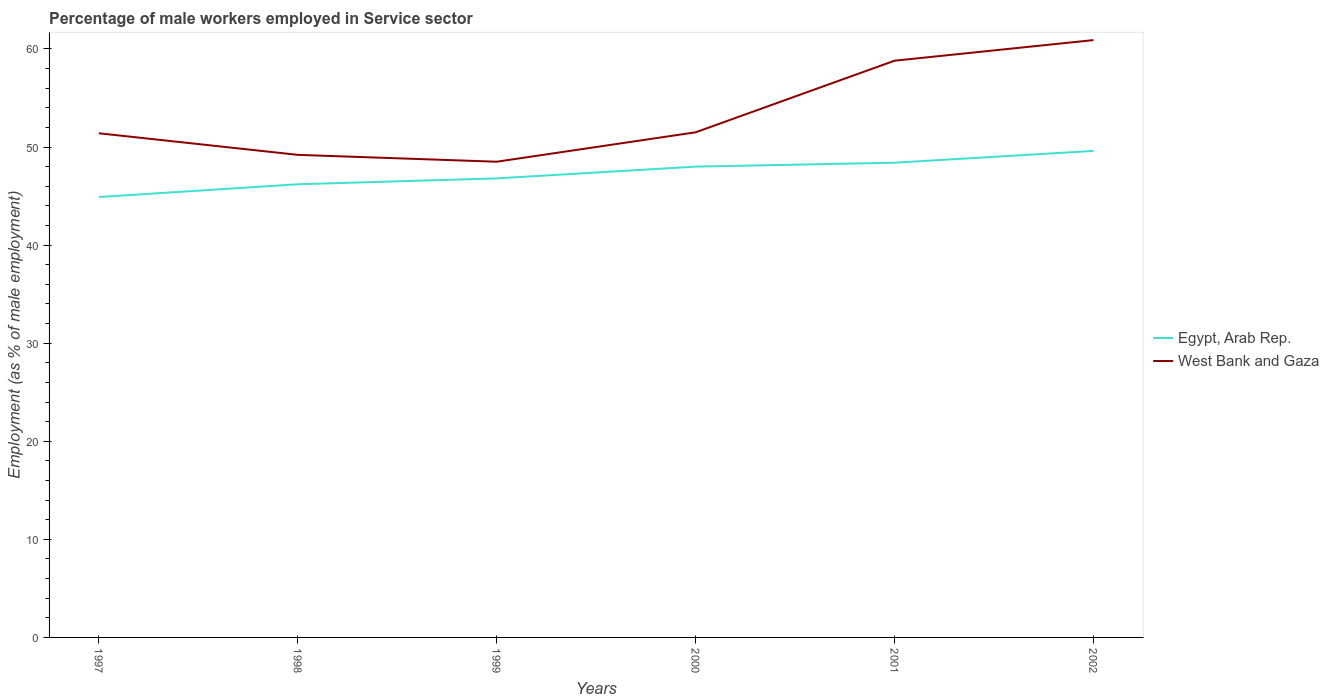Does the line corresponding to Egypt, Arab Rep. intersect with the line corresponding to West Bank and Gaza?
Keep it short and to the point. No. Is the number of lines equal to the number of legend labels?
Your answer should be compact. Yes. Across all years, what is the maximum percentage of male workers employed in Service sector in Egypt, Arab Rep.?
Offer a very short reply. 44.9. What is the total percentage of male workers employed in Service sector in Egypt, Arab Rep. in the graph?
Give a very brief answer. -1.6. What is the difference between the highest and the second highest percentage of male workers employed in Service sector in West Bank and Gaza?
Offer a terse response. 12.4. Is the percentage of male workers employed in Service sector in Egypt, Arab Rep. strictly greater than the percentage of male workers employed in Service sector in West Bank and Gaza over the years?
Ensure brevity in your answer.  Yes. Does the graph contain grids?
Offer a very short reply. No. Where does the legend appear in the graph?
Your answer should be very brief. Center right. How many legend labels are there?
Provide a succinct answer. 2. What is the title of the graph?
Your answer should be very brief. Percentage of male workers employed in Service sector. Does "Saudi Arabia" appear as one of the legend labels in the graph?
Ensure brevity in your answer.  No. What is the label or title of the X-axis?
Your response must be concise. Years. What is the label or title of the Y-axis?
Give a very brief answer. Employment (as % of male employment). What is the Employment (as % of male employment) of Egypt, Arab Rep. in 1997?
Your answer should be very brief. 44.9. What is the Employment (as % of male employment) in West Bank and Gaza in 1997?
Offer a very short reply. 51.4. What is the Employment (as % of male employment) in Egypt, Arab Rep. in 1998?
Keep it short and to the point. 46.2. What is the Employment (as % of male employment) of West Bank and Gaza in 1998?
Keep it short and to the point. 49.2. What is the Employment (as % of male employment) of Egypt, Arab Rep. in 1999?
Offer a very short reply. 46.8. What is the Employment (as % of male employment) of West Bank and Gaza in 1999?
Keep it short and to the point. 48.5. What is the Employment (as % of male employment) of Egypt, Arab Rep. in 2000?
Your answer should be compact. 48. What is the Employment (as % of male employment) in West Bank and Gaza in 2000?
Provide a succinct answer. 51.5. What is the Employment (as % of male employment) of Egypt, Arab Rep. in 2001?
Your answer should be very brief. 48.4. What is the Employment (as % of male employment) of West Bank and Gaza in 2001?
Your answer should be very brief. 58.8. What is the Employment (as % of male employment) in Egypt, Arab Rep. in 2002?
Your response must be concise. 49.6. What is the Employment (as % of male employment) in West Bank and Gaza in 2002?
Provide a short and direct response. 60.9. Across all years, what is the maximum Employment (as % of male employment) of Egypt, Arab Rep.?
Provide a succinct answer. 49.6. Across all years, what is the maximum Employment (as % of male employment) of West Bank and Gaza?
Your answer should be compact. 60.9. Across all years, what is the minimum Employment (as % of male employment) of Egypt, Arab Rep.?
Offer a very short reply. 44.9. Across all years, what is the minimum Employment (as % of male employment) of West Bank and Gaza?
Keep it short and to the point. 48.5. What is the total Employment (as % of male employment) of Egypt, Arab Rep. in the graph?
Your response must be concise. 283.9. What is the total Employment (as % of male employment) of West Bank and Gaza in the graph?
Give a very brief answer. 320.3. What is the difference between the Employment (as % of male employment) of Egypt, Arab Rep. in 1997 and that in 1998?
Offer a terse response. -1.3. What is the difference between the Employment (as % of male employment) in West Bank and Gaza in 1997 and that in 1998?
Your answer should be compact. 2.2. What is the difference between the Employment (as % of male employment) in Egypt, Arab Rep. in 1997 and that in 2000?
Your answer should be compact. -3.1. What is the difference between the Employment (as % of male employment) of Egypt, Arab Rep. in 1997 and that in 2001?
Give a very brief answer. -3.5. What is the difference between the Employment (as % of male employment) in West Bank and Gaza in 1997 and that in 2001?
Offer a very short reply. -7.4. What is the difference between the Employment (as % of male employment) of West Bank and Gaza in 1997 and that in 2002?
Keep it short and to the point. -9.5. What is the difference between the Employment (as % of male employment) in Egypt, Arab Rep. in 1998 and that in 1999?
Your answer should be compact. -0.6. What is the difference between the Employment (as % of male employment) of West Bank and Gaza in 1998 and that in 1999?
Offer a very short reply. 0.7. What is the difference between the Employment (as % of male employment) of West Bank and Gaza in 1998 and that in 2001?
Ensure brevity in your answer.  -9.6. What is the difference between the Employment (as % of male employment) of West Bank and Gaza in 1998 and that in 2002?
Offer a very short reply. -11.7. What is the difference between the Employment (as % of male employment) of Egypt, Arab Rep. in 1999 and that in 2000?
Provide a short and direct response. -1.2. What is the difference between the Employment (as % of male employment) of West Bank and Gaza in 1999 and that in 2001?
Your response must be concise. -10.3. What is the difference between the Employment (as % of male employment) of Egypt, Arab Rep. in 2000 and that in 2001?
Provide a succinct answer. -0.4. What is the difference between the Employment (as % of male employment) of West Bank and Gaza in 2000 and that in 2001?
Make the answer very short. -7.3. What is the difference between the Employment (as % of male employment) of Egypt, Arab Rep. in 2000 and that in 2002?
Offer a terse response. -1.6. What is the difference between the Employment (as % of male employment) of Egypt, Arab Rep. in 2001 and that in 2002?
Offer a terse response. -1.2. What is the difference between the Employment (as % of male employment) of Egypt, Arab Rep. in 1997 and the Employment (as % of male employment) of West Bank and Gaza in 1998?
Your answer should be very brief. -4.3. What is the difference between the Employment (as % of male employment) in Egypt, Arab Rep. in 1997 and the Employment (as % of male employment) in West Bank and Gaza in 2001?
Keep it short and to the point. -13.9. What is the difference between the Employment (as % of male employment) in Egypt, Arab Rep. in 1997 and the Employment (as % of male employment) in West Bank and Gaza in 2002?
Ensure brevity in your answer.  -16. What is the difference between the Employment (as % of male employment) in Egypt, Arab Rep. in 1998 and the Employment (as % of male employment) in West Bank and Gaza in 2000?
Your response must be concise. -5.3. What is the difference between the Employment (as % of male employment) of Egypt, Arab Rep. in 1998 and the Employment (as % of male employment) of West Bank and Gaza in 2002?
Your answer should be very brief. -14.7. What is the difference between the Employment (as % of male employment) in Egypt, Arab Rep. in 1999 and the Employment (as % of male employment) in West Bank and Gaza in 2000?
Offer a terse response. -4.7. What is the difference between the Employment (as % of male employment) of Egypt, Arab Rep. in 1999 and the Employment (as % of male employment) of West Bank and Gaza in 2002?
Ensure brevity in your answer.  -14.1. What is the difference between the Employment (as % of male employment) of Egypt, Arab Rep. in 2000 and the Employment (as % of male employment) of West Bank and Gaza in 2001?
Give a very brief answer. -10.8. What is the average Employment (as % of male employment) of Egypt, Arab Rep. per year?
Offer a very short reply. 47.32. What is the average Employment (as % of male employment) of West Bank and Gaza per year?
Offer a terse response. 53.38. In the year 1997, what is the difference between the Employment (as % of male employment) in Egypt, Arab Rep. and Employment (as % of male employment) in West Bank and Gaza?
Your response must be concise. -6.5. In the year 2000, what is the difference between the Employment (as % of male employment) in Egypt, Arab Rep. and Employment (as % of male employment) in West Bank and Gaza?
Keep it short and to the point. -3.5. In the year 2002, what is the difference between the Employment (as % of male employment) in Egypt, Arab Rep. and Employment (as % of male employment) in West Bank and Gaza?
Your answer should be very brief. -11.3. What is the ratio of the Employment (as % of male employment) in Egypt, Arab Rep. in 1997 to that in 1998?
Provide a short and direct response. 0.97. What is the ratio of the Employment (as % of male employment) of West Bank and Gaza in 1997 to that in 1998?
Your answer should be compact. 1.04. What is the ratio of the Employment (as % of male employment) of Egypt, Arab Rep. in 1997 to that in 1999?
Provide a short and direct response. 0.96. What is the ratio of the Employment (as % of male employment) in West Bank and Gaza in 1997 to that in 1999?
Give a very brief answer. 1.06. What is the ratio of the Employment (as % of male employment) of Egypt, Arab Rep. in 1997 to that in 2000?
Give a very brief answer. 0.94. What is the ratio of the Employment (as % of male employment) of Egypt, Arab Rep. in 1997 to that in 2001?
Provide a short and direct response. 0.93. What is the ratio of the Employment (as % of male employment) in West Bank and Gaza in 1997 to that in 2001?
Your response must be concise. 0.87. What is the ratio of the Employment (as % of male employment) of Egypt, Arab Rep. in 1997 to that in 2002?
Offer a terse response. 0.91. What is the ratio of the Employment (as % of male employment) in West Bank and Gaza in 1997 to that in 2002?
Your answer should be very brief. 0.84. What is the ratio of the Employment (as % of male employment) in Egypt, Arab Rep. in 1998 to that in 1999?
Keep it short and to the point. 0.99. What is the ratio of the Employment (as % of male employment) of West Bank and Gaza in 1998 to that in 1999?
Give a very brief answer. 1.01. What is the ratio of the Employment (as % of male employment) of Egypt, Arab Rep. in 1998 to that in 2000?
Your response must be concise. 0.96. What is the ratio of the Employment (as % of male employment) of West Bank and Gaza in 1998 to that in 2000?
Your answer should be compact. 0.96. What is the ratio of the Employment (as % of male employment) in Egypt, Arab Rep. in 1998 to that in 2001?
Your answer should be very brief. 0.95. What is the ratio of the Employment (as % of male employment) of West Bank and Gaza in 1998 to that in 2001?
Keep it short and to the point. 0.84. What is the ratio of the Employment (as % of male employment) of Egypt, Arab Rep. in 1998 to that in 2002?
Provide a succinct answer. 0.93. What is the ratio of the Employment (as % of male employment) of West Bank and Gaza in 1998 to that in 2002?
Offer a terse response. 0.81. What is the ratio of the Employment (as % of male employment) in West Bank and Gaza in 1999 to that in 2000?
Make the answer very short. 0.94. What is the ratio of the Employment (as % of male employment) of Egypt, Arab Rep. in 1999 to that in 2001?
Your answer should be compact. 0.97. What is the ratio of the Employment (as % of male employment) of West Bank and Gaza in 1999 to that in 2001?
Provide a short and direct response. 0.82. What is the ratio of the Employment (as % of male employment) in Egypt, Arab Rep. in 1999 to that in 2002?
Your answer should be very brief. 0.94. What is the ratio of the Employment (as % of male employment) in West Bank and Gaza in 1999 to that in 2002?
Give a very brief answer. 0.8. What is the ratio of the Employment (as % of male employment) in West Bank and Gaza in 2000 to that in 2001?
Your answer should be very brief. 0.88. What is the ratio of the Employment (as % of male employment) in West Bank and Gaza in 2000 to that in 2002?
Your answer should be compact. 0.85. What is the ratio of the Employment (as % of male employment) in Egypt, Arab Rep. in 2001 to that in 2002?
Offer a terse response. 0.98. What is the ratio of the Employment (as % of male employment) in West Bank and Gaza in 2001 to that in 2002?
Offer a very short reply. 0.97. What is the difference between the highest and the second highest Employment (as % of male employment) in Egypt, Arab Rep.?
Give a very brief answer. 1.2. What is the difference between the highest and the second highest Employment (as % of male employment) of West Bank and Gaza?
Provide a short and direct response. 2.1. What is the difference between the highest and the lowest Employment (as % of male employment) of Egypt, Arab Rep.?
Offer a very short reply. 4.7. What is the difference between the highest and the lowest Employment (as % of male employment) in West Bank and Gaza?
Give a very brief answer. 12.4. 